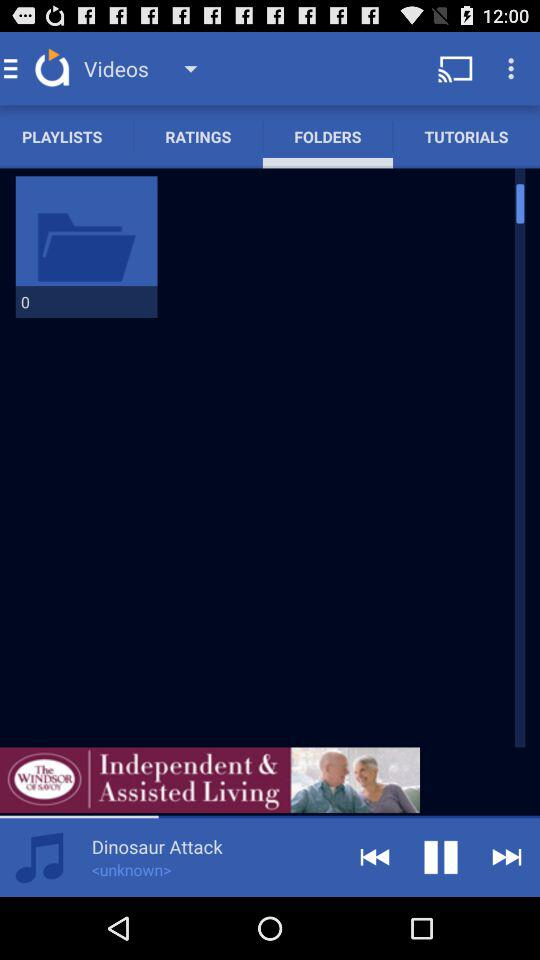Which option is selected? The selected option is "FOLDERS". 